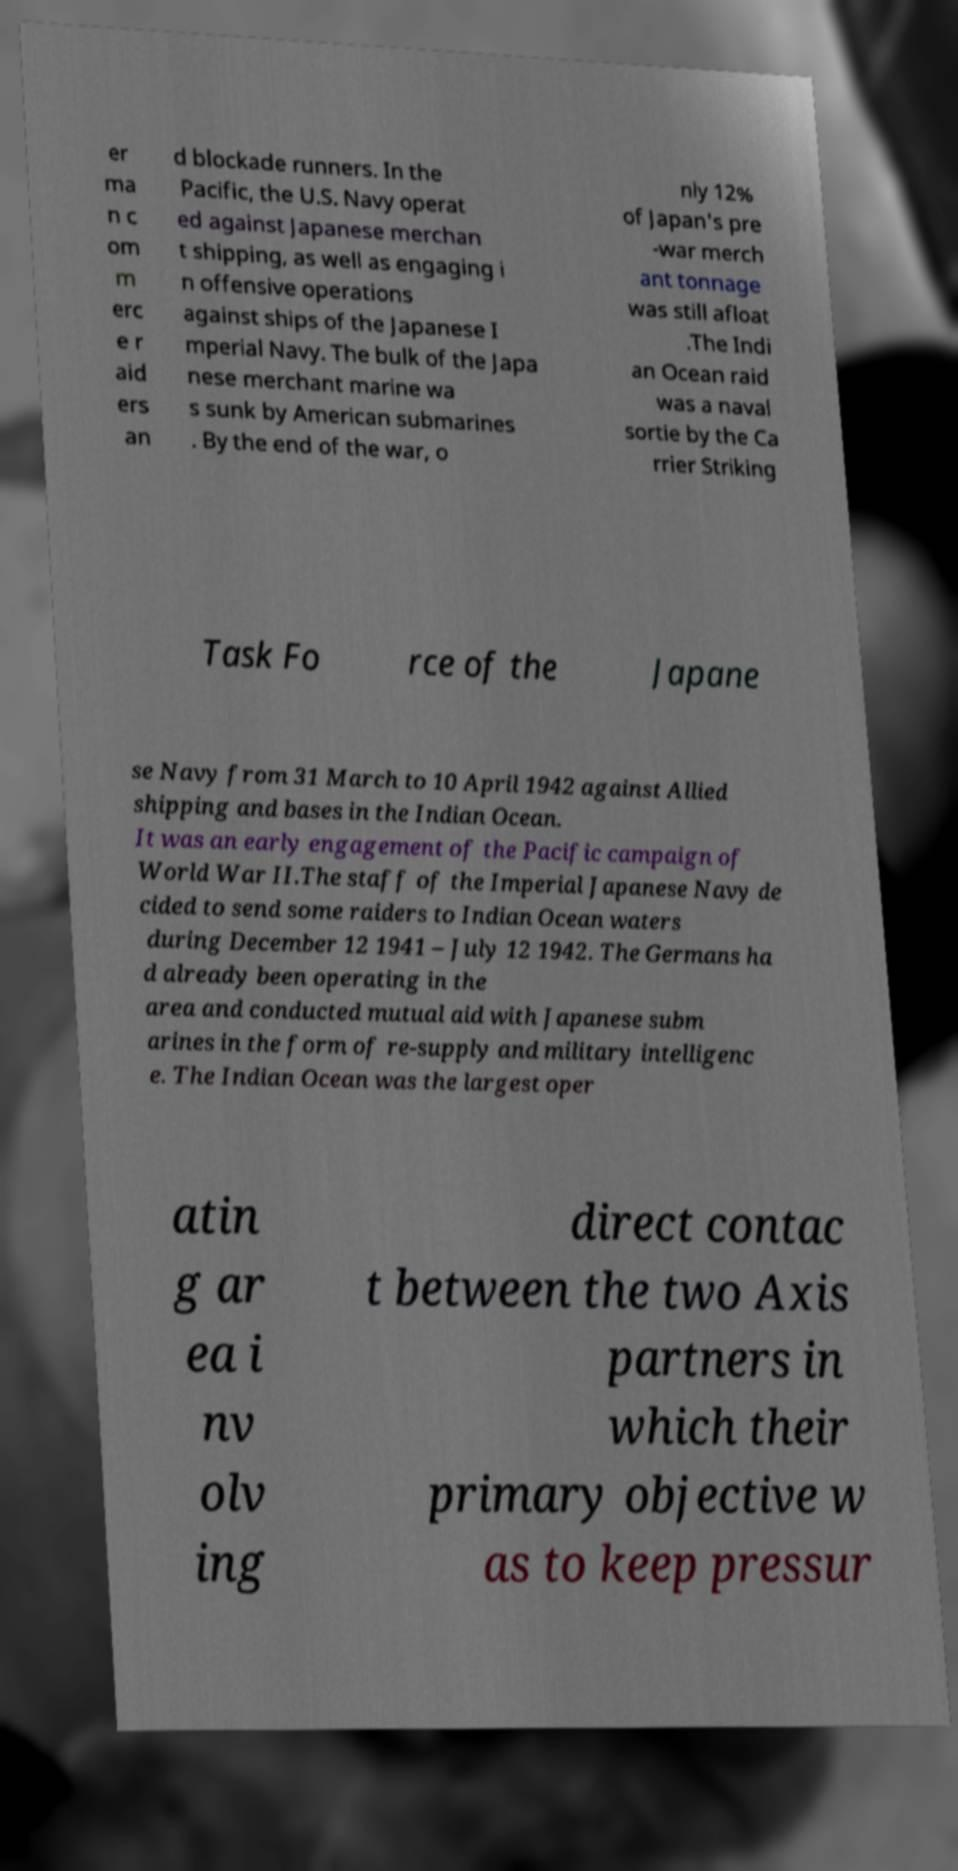Can you read and provide the text displayed in the image?This photo seems to have some interesting text. Can you extract and type it out for me? er ma n c om m erc e r aid ers an d blockade runners. In the Pacific, the U.S. Navy operat ed against Japanese merchan t shipping, as well as engaging i n offensive operations against ships of the Japanese I mperial Navy. The bulk of the Japa nese merchant marine wa s sunk by American submarines . By the end of the war, o nly 12% of Japan's pre -war merch ant tonnage was still afloat .The Indi an Ocean raid was a naval sortie by the Ca rrier Striking Task Fo rce of the Japane se Navy from 31 March to 10 April 1942 against Allied shipping and bases in the Indian Ocean. It was an early engagement of the Pacific campaign of World War II.The staff of the Imperial Japanese Navy de cided to send some raiders to Indian Ocean waters during December 12 1941 – July 12 1942. The Germans ha d already been operating in the area and conducted mutual aid with Japanese subm arines in the form of re-supply and military intelligenc e. The Indian Ocean was the largest oper atin g ar ea i nv olv ing direct contac t between the two Axis partners in which their primary objective w as to keep pressur 